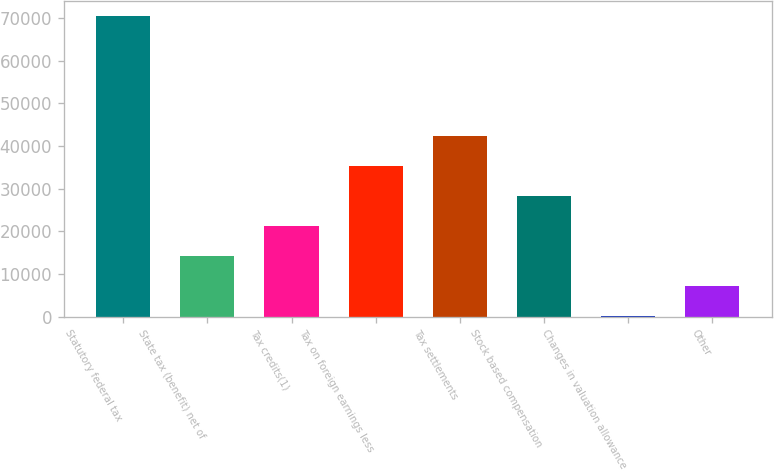<chart> <loc_0><loc_0><loc_500><loc_500><bar_chart><fcel>Statutory federal tax<fcel>State tax (benefit) net of<fcel>Tax credits(1)<fcel>Tax on foreign earnings less<fcel>Tax settlements<fcel>Stock based compensation<fcel>Changes in valuation allowance<fcel>Other<nl><fcel>70397<fcel>14087.4<fcel>21126.1<fcel>35203.5<fcel>42242.2<fcel>28164.8<fcel>10<fcel>7048.7<nl></chart> 